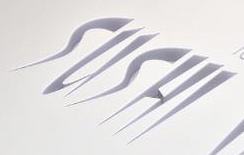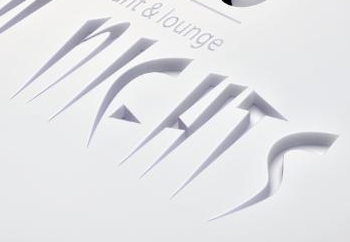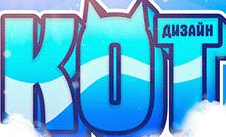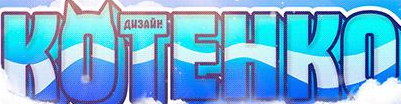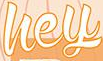Read the text from these images in sequence, separated by a semicolon. SUSHI; NIEHTS; KOT; KOTEHKO; hey 